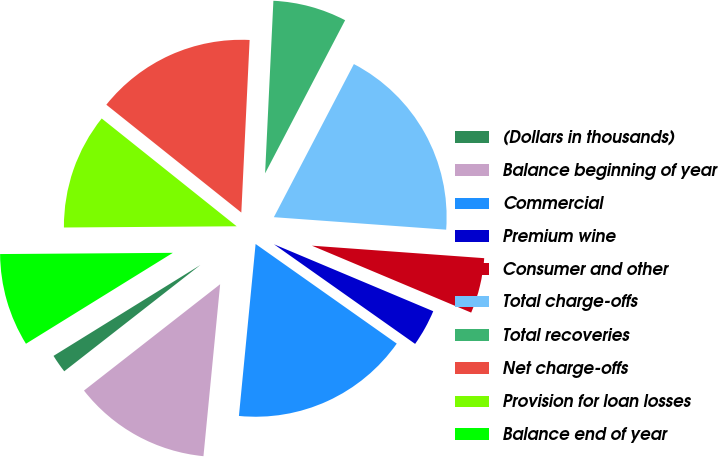Convert chart. <chart><loc_0><loc_0><loc_500><loc_500><pie_chart><fcel>(Dollars in thousands)<fcel>Balance beginning of year<fcel>Commercial<fcel>Premium wine<fcel>Consumer and other<fcel>Total charge-offs<fcel>Total recoveries<fcel>Net charge-offs<fcel>Provision for loan losses<fcel>Balance end of year<nl><fcel>1.73%<fcel>12.91%<fcel>16.76%<fcel>3.45%<fcel>5.18%<fcel>18.49%<fcel>6.9%<fcel>15.04%<fcel>10.84%<fcel>8.71%<nl></chart> 